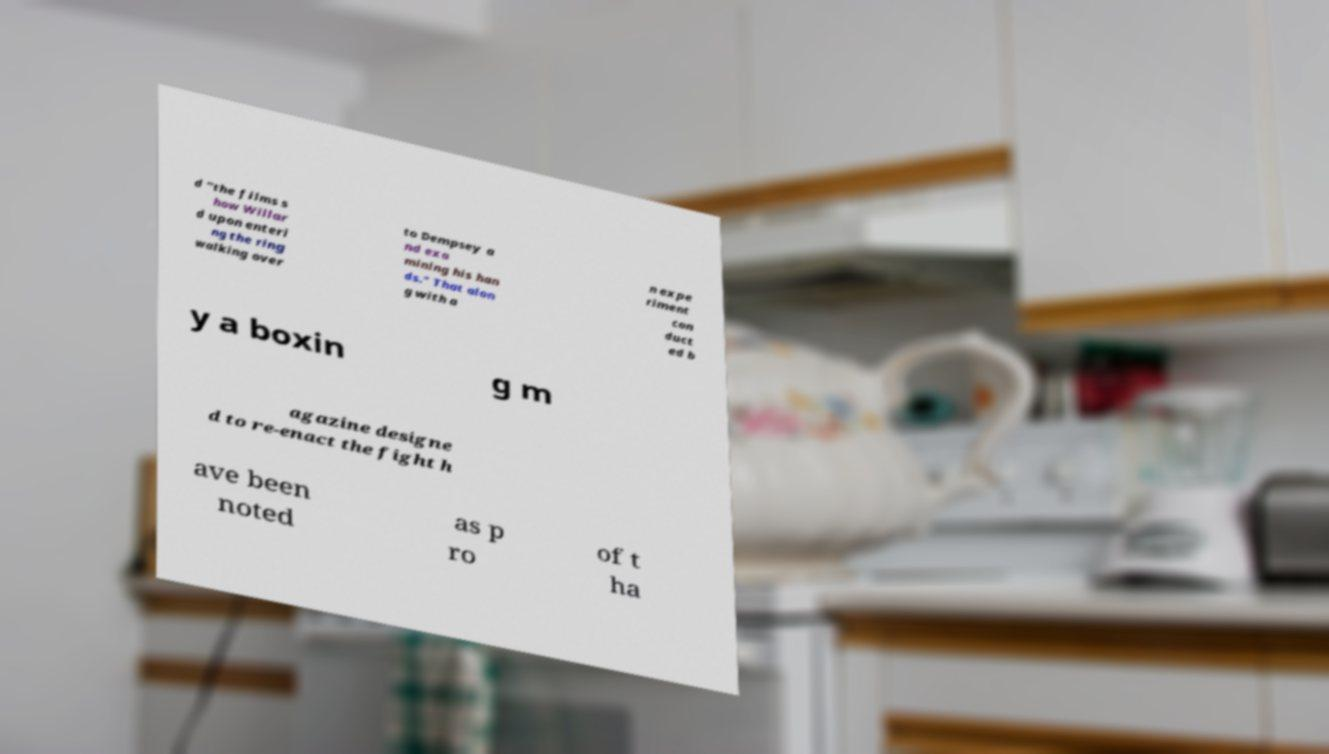What messages or text are displayed in this image? I need them in a readable, typed format. d "the films s how Willar d upon enteri ng the ring walking over to Dempsey a nd exa mining his han ds." That alon g with a n expe riment con duct ed b y a boxin g m agazine designe d to re-enact the fight h ave been noted as p ro of t ha 